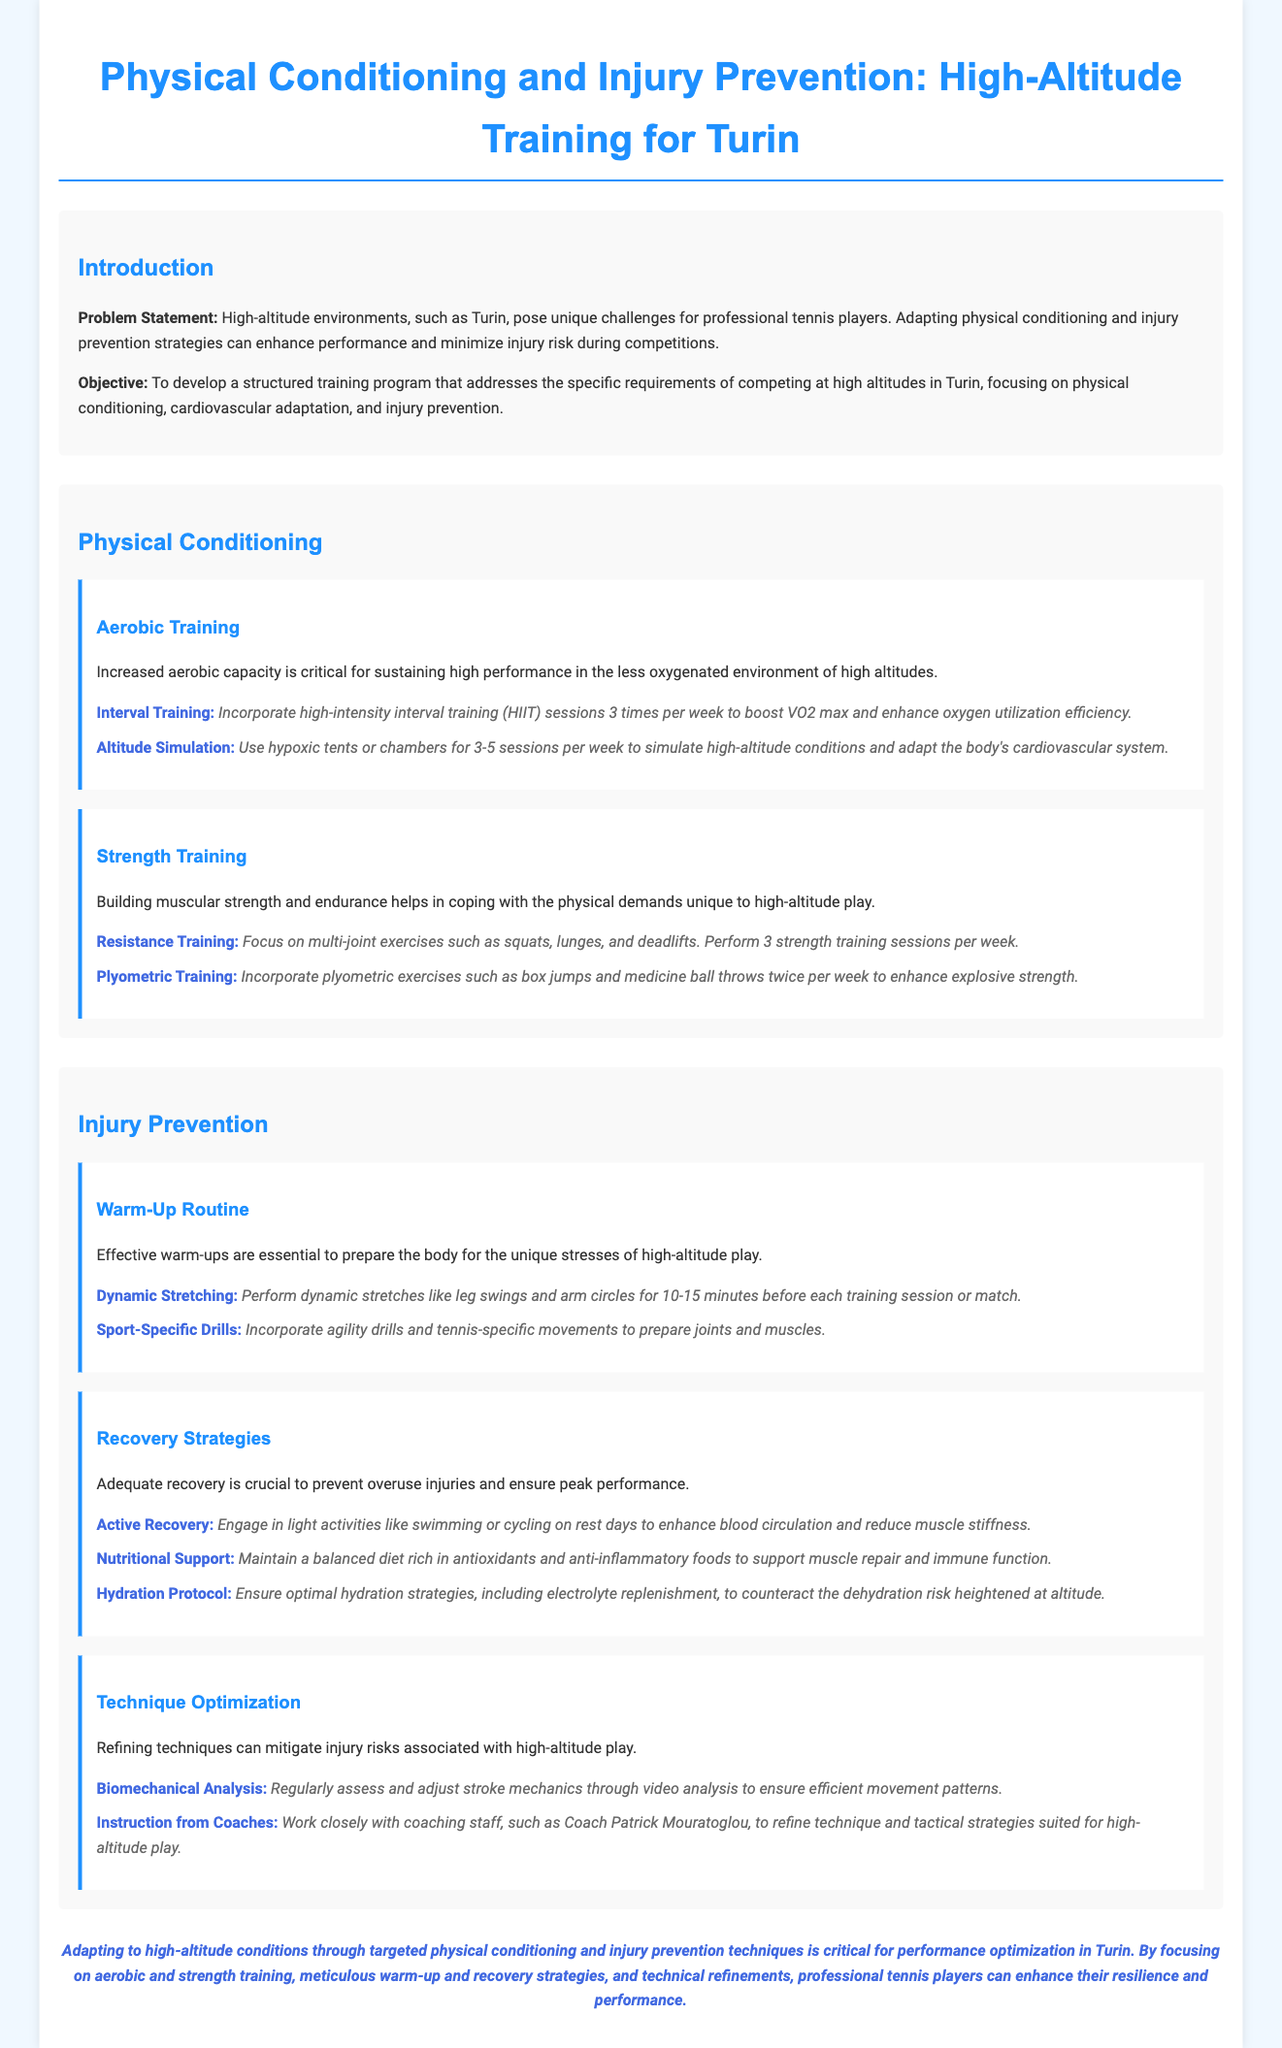What is the problem statement? The problem statement addresses the unique challenges professional tennis players face in high-altitude environments like Turin and emphasizes the need for tailored strategies.
Answer: High-altitude environments, such as Turin, pose unique challenges for professional tennis players What is the primary objective of the training program? The objective is to create a structured training program focusing on physical conditioning, cardiovascular adaptation, and injury prevention for high-altitude competitions.
Answer: To develop a structured training program that addresses the specific requirements of competing at high altitudes in Turin How many strength training sessions are recommended per week? The document states that players should perform strength training three times a week to build muscular strength and endurance.
Answer: 3 strength training sessions per week What type of training involves using hypoxic tents? The training type that involves hypoxic tents is focused on simulating high-altitude conditions to adapt the cardiovascular system.
Answer: Altitude Simulation What does the warm-up routine include according to the document? The warm-up routine includes performing dynamic stretches and sport-specific drills to prepare for high-altitude play.
Answer: Dynamic Stretching and Sport-Specific Drills How often should plyometric exercises be incorporated into the training program? The frequency for incorporating plyometric exercises into the training program is specified twice a week.
Answer: Twice per week What essential recovery strategy is mentioned to enhance blood circulation? Engaging in light activities such as swimming or cycling on rest days is recommended for enhancing blood circulation.
Answer: Active Recovery Who should players work closely with for technique refinement? The document suggests that players should work closely with coaching staff for technique and tactical strategy adjustments.
Answer: Coaching staff, such as Coach Patrick Mouratoglou 